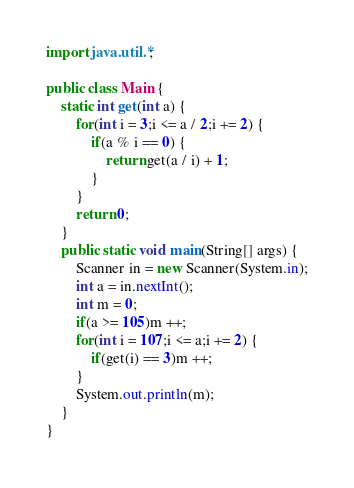Convert code to text. <code><loc_0><loc_0><loc_500><loc_500><_Java_>import java.util.*;

public class Main {
	static int get(int a) {
		for(int i = 3;i <= a / 2;i += 2) {
			if(a % i == 0) {
				return get(a / i) + 1;
			}
		}
		return 0;
	}
	public static void main(String[] args) {
		Scanner in = new Scanner(System.in);
		int a = in.nextInt();
		int m = 0;
		if(a >= 105)m ++;
		for(int i = 107;i <= a;i += 2) {
			if(get(i) == 3)m ++;
		}
		System.out.println(m);
	}
}
</code> 